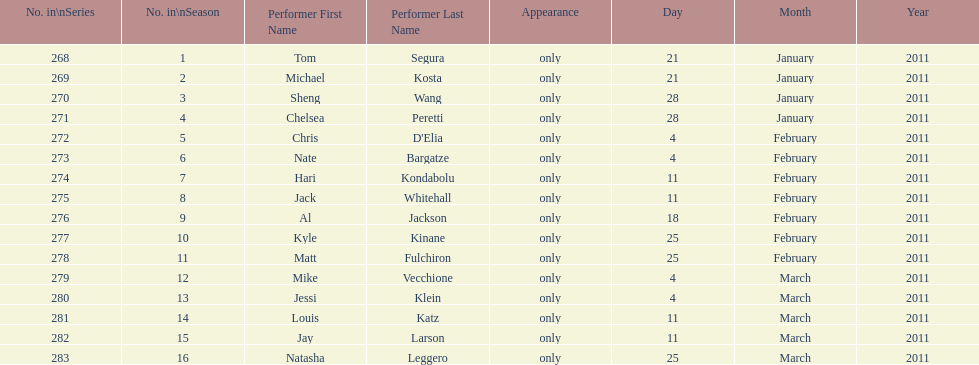What were the total number of air dates in february? 7. 